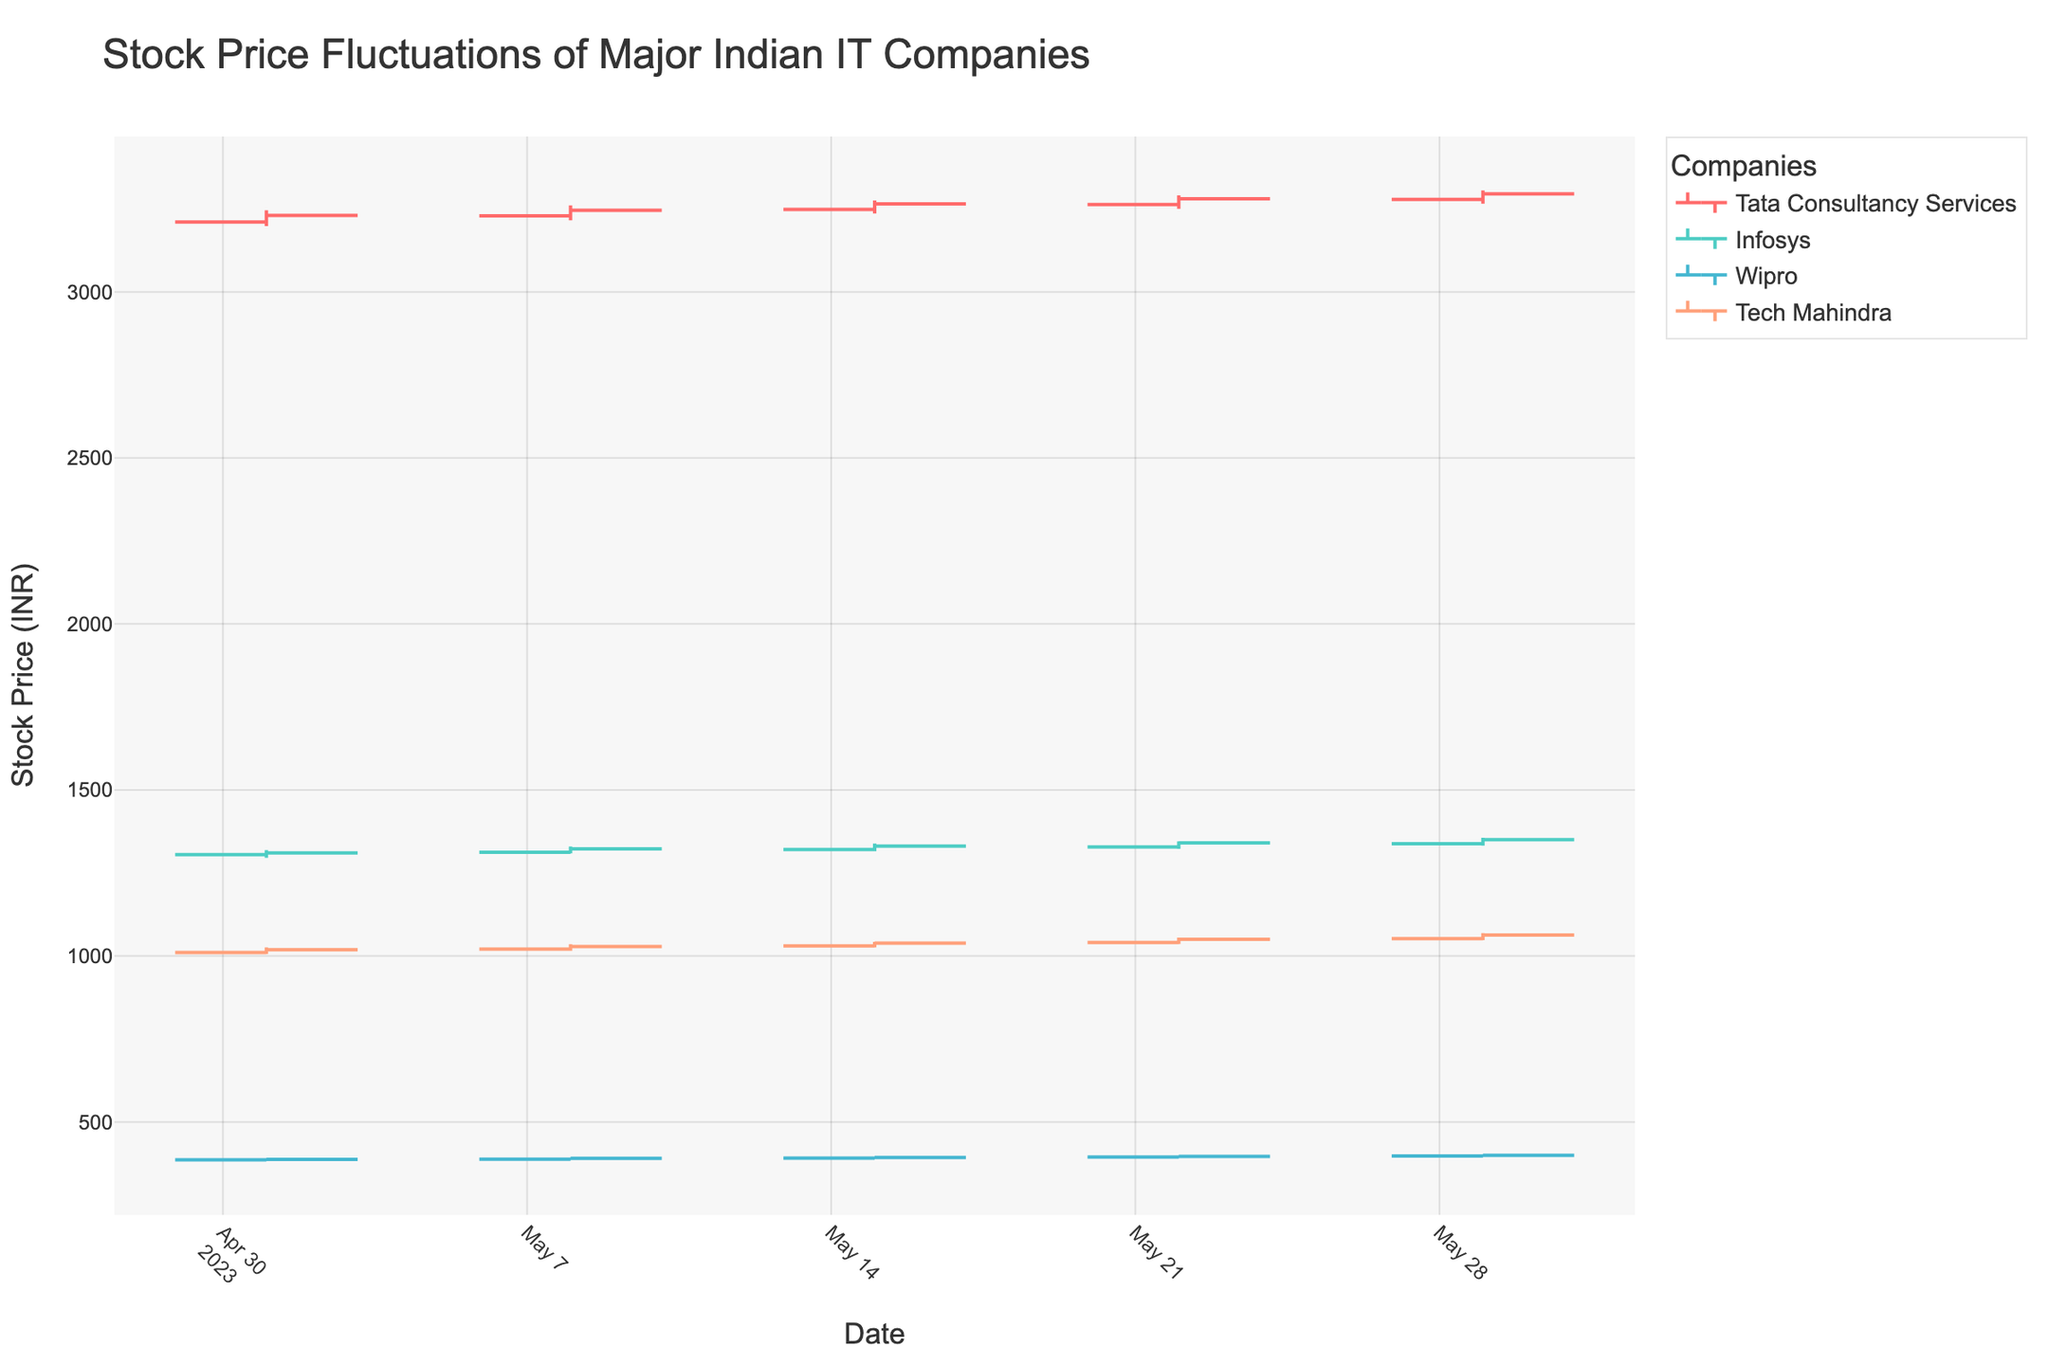Which company had the highest closing price on May 08, 2023? On the date of May 08, 2023, look at the closing prices for each company and identify the highest value. Tata Consultancy Services closed at 3245.60, Infosys at 1322.50, Wipro at 390.70, and Tech Mahindra at 1028.40. The highest closing price on that date is 3245.60 by Tata Consultancy Services.
Answer: Tata Consultancy Services What is the average opening price for Infosys across all the dates in the dataset? To find the average opening price for Infosys, sum all the opening prices for the given dates and divide by the number of dates. The opening prices are 1305.25, 1312.40, 1320.75, 1328.50, and 1338.20. The sum is 6605.10. There are 5 dates, so the average is 6605.10 / 5 = 1321.02.
Answer: 1321.02 Between Wipro and Tech Mahindra, which company had a higher lowest price on May 15, 2023? Examine the low prices for both Wipro and Tech Mahindra on May 15, 2023. Wipro has a low price of 388.60, and Tech Mahindra has a low price of 1025.70. Comparing these two, Tech Mahindra has the higher lowest price.
Answer: Tech Mahindra What is the overall trend in the closing prices for Tata Consultancy Services over the given dates? Observe the closing prices for Tata Consultancy Services on each date: 3230.40, 3245.60, 3265.30, 3280.70, and 3295.30. The prices are increasing over the given dates.
Answer: Increasing Which company showed the most significant increase in closing price from May 22, 2023, to May 29, 2023? Calculate the difference in closing prices from May 22, 2023, to May 29, 2023, for each company. Tata Consultancy Services increased by 3295.30 - 3280.70 = 14.6, Infosys by 1350.40 - 1340.25 = 10.15, Wipro by 399.60 - 396.40 = 3.2, and Tech Mahindra by 1062.90 - 1050.20 = 12.7. The most significant increase is 14.6 for Tata Consultancy Services.
Answer: Tata Consultancy Services On which date did Wipro have the highest closing price, and what was it? Look at the closing prices for Wipro across all dates and identify the highest value along with the corresponding date. The closing prices are 387.30, 390.70, 393.20, 396.40, and 399.60. The highest closing price is 399.60 on May 29, 2023.
Answer: May 29, 2023, 399.60 How many companies had an increasing stock trend on May 29, 2023? To determine how many companies had an increasing trend on May 29, 2023, compare the open and close prices for each company. An increasing trend means the closing price is higher than the opening price. For Tata Consultancy Services: 3295.30 > 3278.40, Infosys: 1350.40 > 1338.20, Wipro: 399.60 > 397.80, and Tech Mahindra: 1062.90 > 1052.30. All four companies had an increasing stock trend on this date.
Answer: 4 Which company had the smallest range (High - Low) on May 08, 2023? Calculate the range for each company on May 08, 2023. Tata Consultancy Services: 3260.40 - 3215.30 = 45.10, Infosys: 1329.75 - 1308.90 = 20.85, Wipro: 392.80 - 385.50 = 7.30, and Tech Mahindra: 1035.25 - 1015.80 = 19.45. The smallest range is 7.30 for Wipro.
Answer: Wipro Compare the highest price of Tech Mahindra on May 29, 2023, to its highest price on May 08, 2023. Which one is greater and by how much? On May 29, 2023, Tech Mahindra's highest price was 1068.75. On May 08, 2023, it was 1035.25. The difference is 1068.75 - 1035.25 = 33.5. The highest price on May 29 is greater by 33.5.
Answer: May 29, 2023, by 33.5 